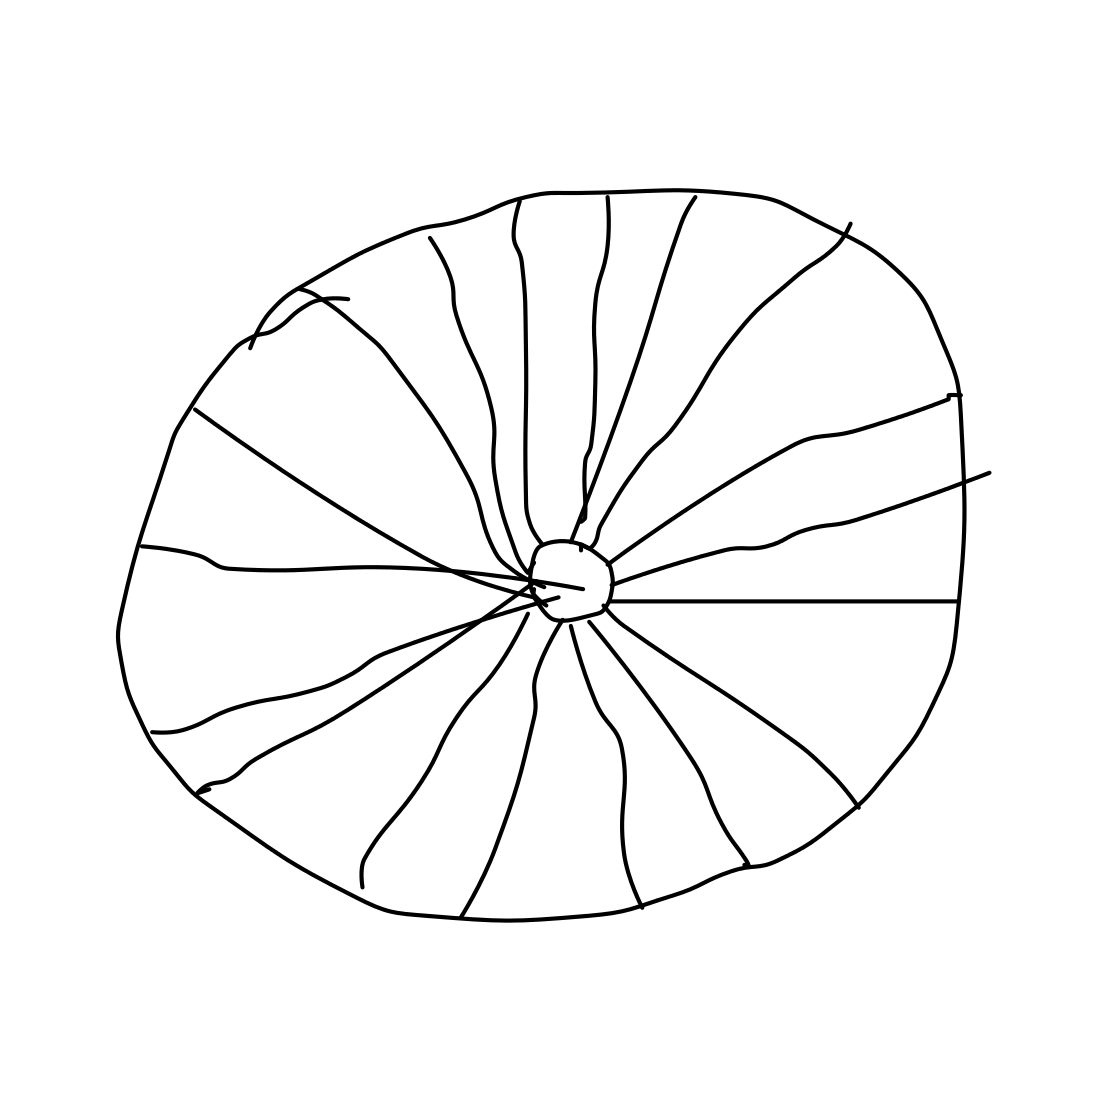What might be the practical use of such a wheel design? Given its simple and sturdy design, this type of wheel could be used in basic mechanical devices where strength and reliability are more important than intricate detailing. It could be ideal for educational models to demonstrate the basic functionality of wheel mechanics. 